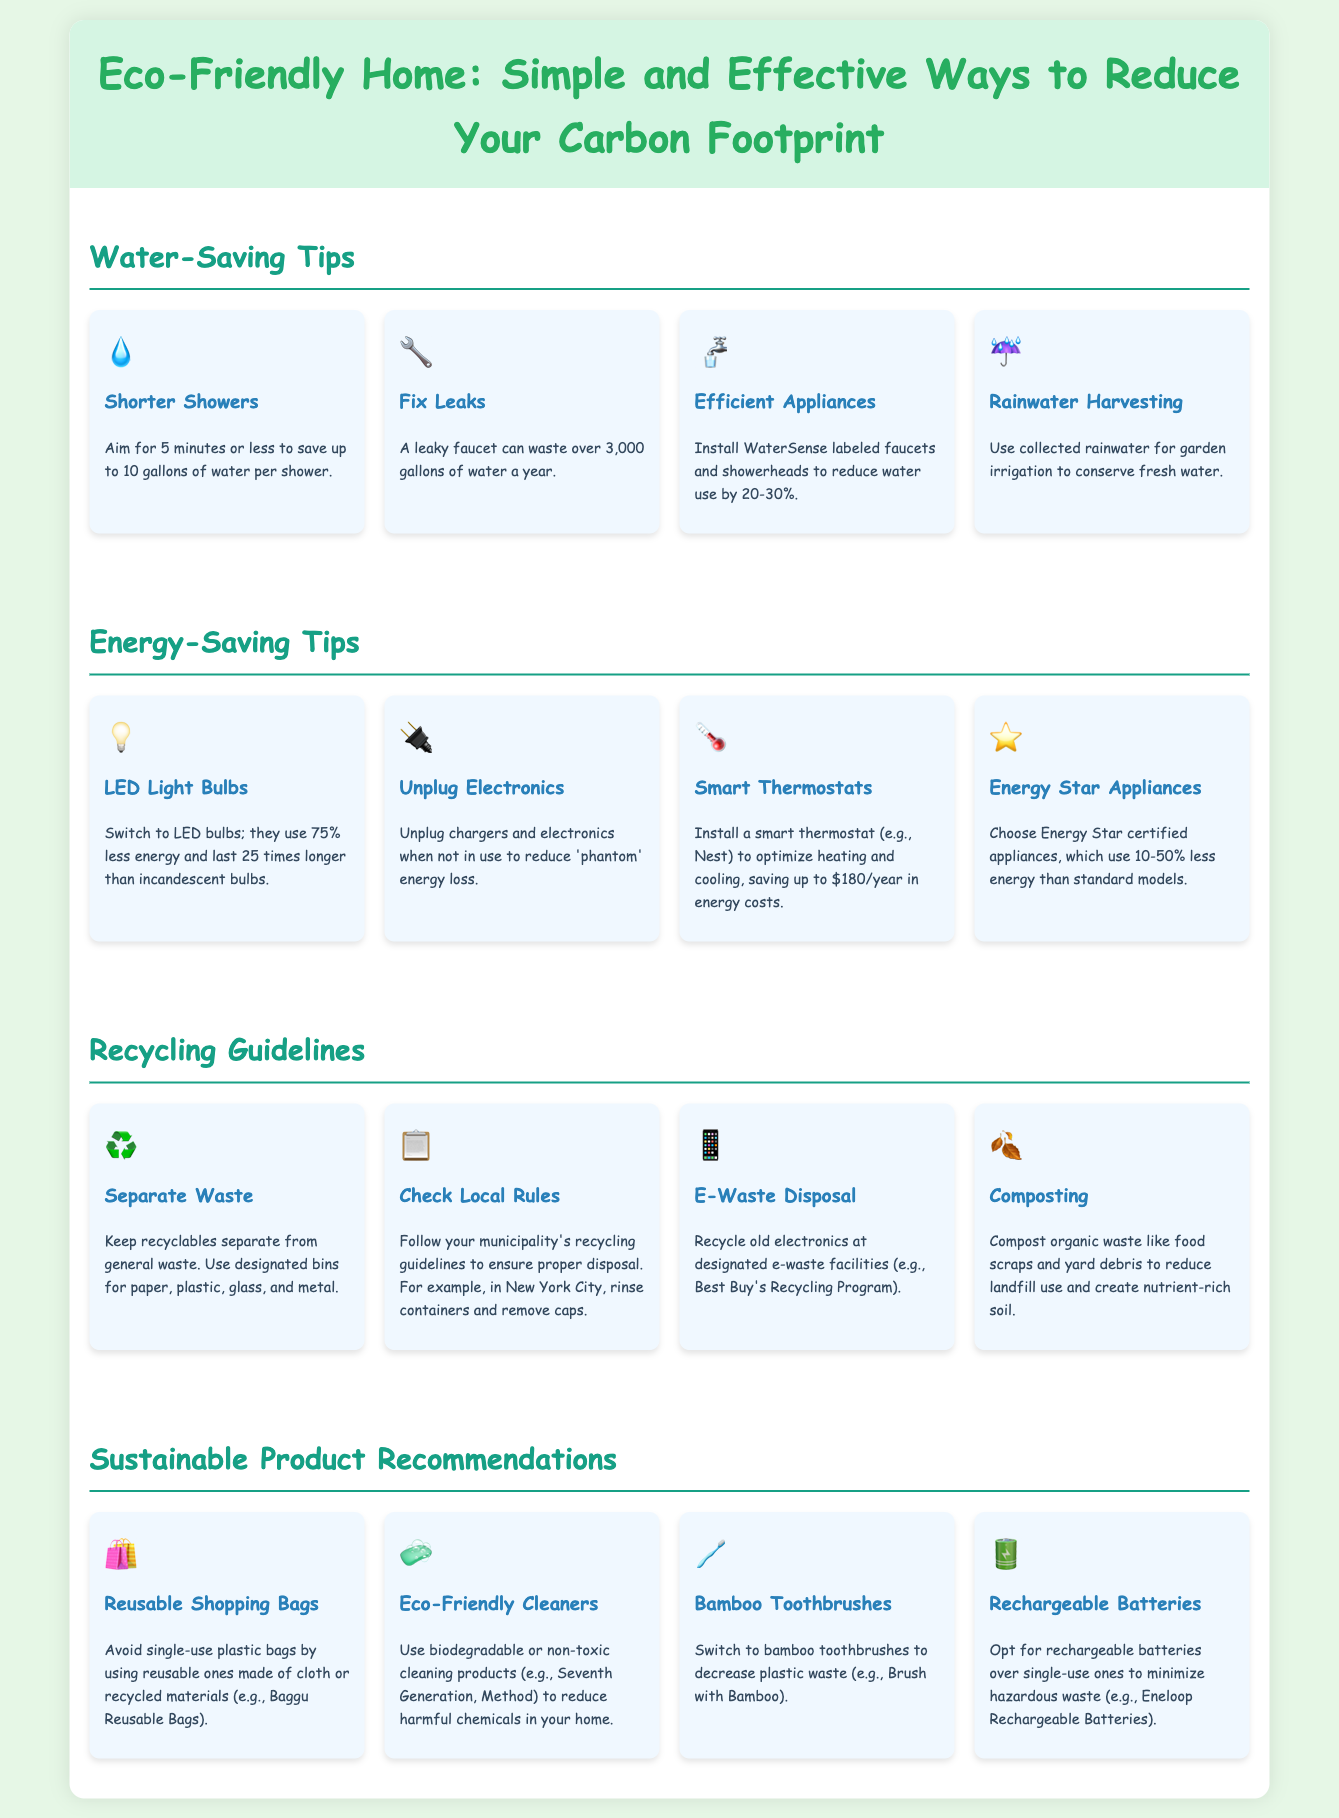What is the maximum water saved by shorter showers? Shorter showers can save up to 10 gallons of water per shower, as stated in the water-saving tips section.
Answer: 10 gallons How much energy do LED bulbs use compared to incandescent bulbs? The infographic states that LED bulbs use 75% less energy than incandescent bulbs.
Answer: 75% What should you do with a leaky faucet? The document advises fixing leaks, as they can waste over 3,000 gallons of water a year.
Answer: Fix leaks What is one way to recycle old electronics? The guidelines recommend recycling old electronics at designated e-waste facilities, such as Best Buy's Recycling Program.
Answer: Best Buy's Recycling Program What is a sustainable alternative to single-use plastic bags? The document suggests using reusable shopping bags made of cloth or recycled materials, like Baggu Reusable Bags.
Answer: Reusable shopping bags How much can a smart thermostat save on energy costs per year? The energy-saving tips include that a smart thermostat can save up to $180 annually in energy costs.
Answer: $180 What kind of cleaning products does the document recommend? It suggests using biodegradable or non-toxic cleaning products to reduce harmful chemicals in the home.
Answer: Eco-Friendly Cleaners What is a recommended practice for composting? The document states that you should compost organic waste like food scraps and yard debris to reduce landfill use.
Answer: Compost organic waste 